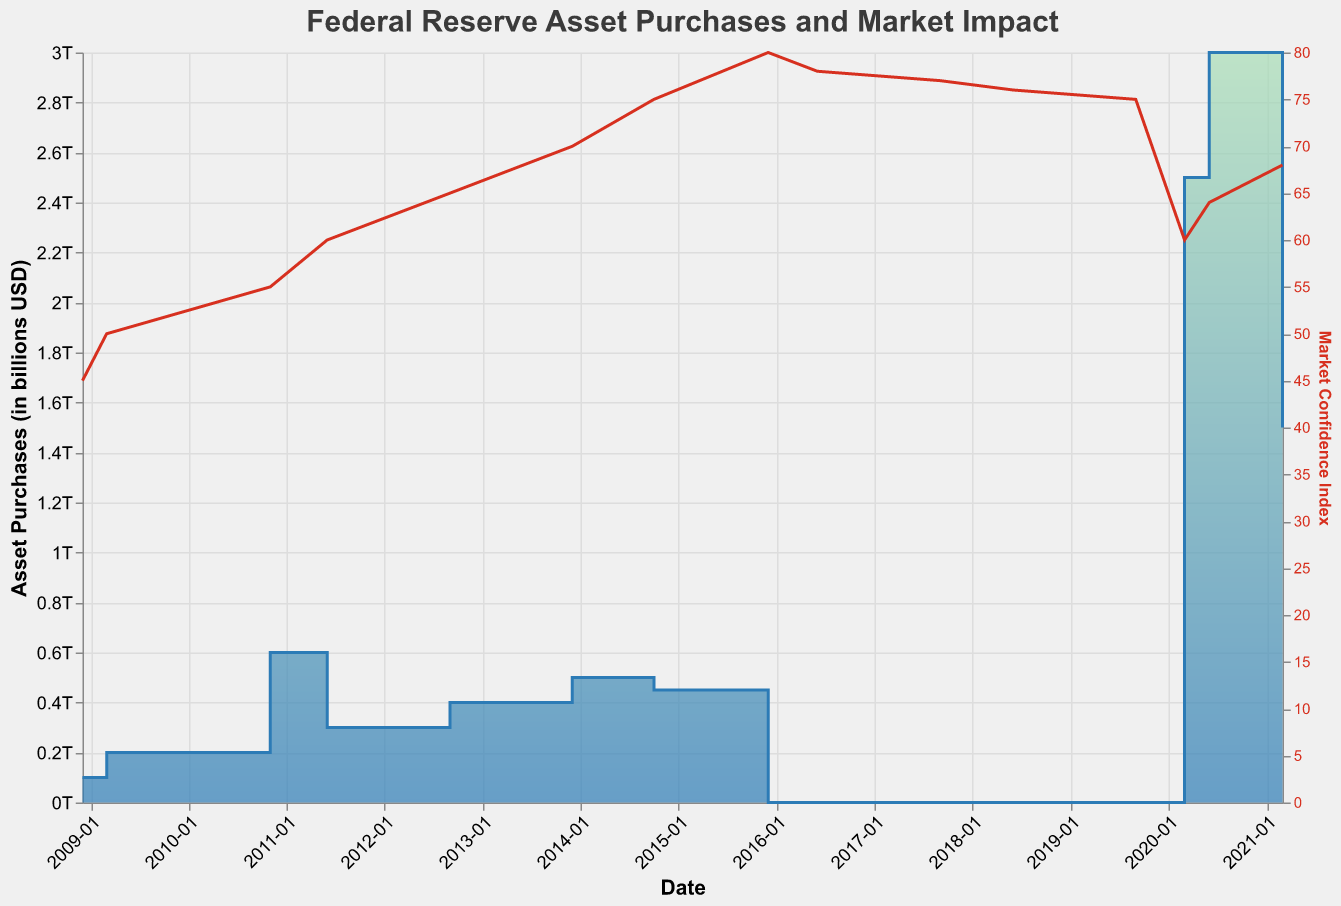What is the title of the figure? The title of a figure is usually located at the top of the chart and is prominently displayed. In this case, it reads: "Federal Reserve Asset Purchases and Market Impact".
Answer: Federal Reserve Asset Purchases and Market Impact What is the highest value of asset purchases and when did it occur? To find the highest value of asset purchases, visually inspect the vertical y-axis for "Asset Purchases" and look for the peak of the step area. The highest value is 3000000000000, which occurs in June 2020.
Answer: 3000000000000, June 2020 How did the market confidence index behave from December 2015 to June 2020? Examine the "Market Confidence Index" line, which uses a separate y-axis and is colored differently. The index rose from 80 in December 2015 to a peak around March 2018 and then gradually dropped to 60 by March 2020 before slightly increasing again.
Answer: Rose to peak in March 2018, then gradually decreased to 60 by March 2020 What is the sum of asset purchases from 2008 to 2014? Sum the asset purchases from all the dates between 2008 and 2014: 100000000000 + 200000000000 + 600000000000 + 300000000000 + 400000000000 + 500000000000 + 450000000000 = 2550000000000.
Answer: 2550000000000 Which date showed a negative bond yield change and what was the corresponding stock market change? Look for the bond yield change with a negative value and note the corresponding date and stock market change. This occurs on March 2020 with a bond yield change of -0.01 and the stock market change was -0.1.
Answer: March 2020, -0.1 How does the stock market change correlate with market confidence index changes over time? Observe the trends of both the stock market change and market confidence index lines over time. Correlating these visually, both generally show a positive relationship where an increase in stock market changes often aligns with an increase in the market confidence index.
Answer: Positive correlation What is the average bond yield change for periods when asset purchases were non-zero? Calculate the bond yield change during non-zero periods: (0.02 + 0.015 + 0.01 + 0.008 + 0.009 + 0.007 + 0.006 - 0.01 + 0.005 + 0.0045) / 10 = 0.00745.
Answer: 0.00745 Compare the bond yield change and stock market change for the first and last dates on the chart. Compare both values for December 2008 and March 2021. Bond yield change was 0.02 in 2008 and 0.0045 in 2021. Stock market change was -0.05 in 2008 and 0.065 in 2021.
Answer: Bond yield change decreased, stock market change increased What unique pattern can you identify in the step area chart specific to asset purchases? The step area chart shows distinct flat segments followed by sudden vertical jumps, indicating periods of no purchases followed by discrete large-scale interventions by the Federal Reserve.
Answer: Sudden vertical jumps after flat segments 